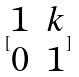<formula> <loc_0><loc_0><loc_500><loc_500>[ \begin{matrix} 1 & k \\ 0 & 1 \end{matrix} ]</formula> 